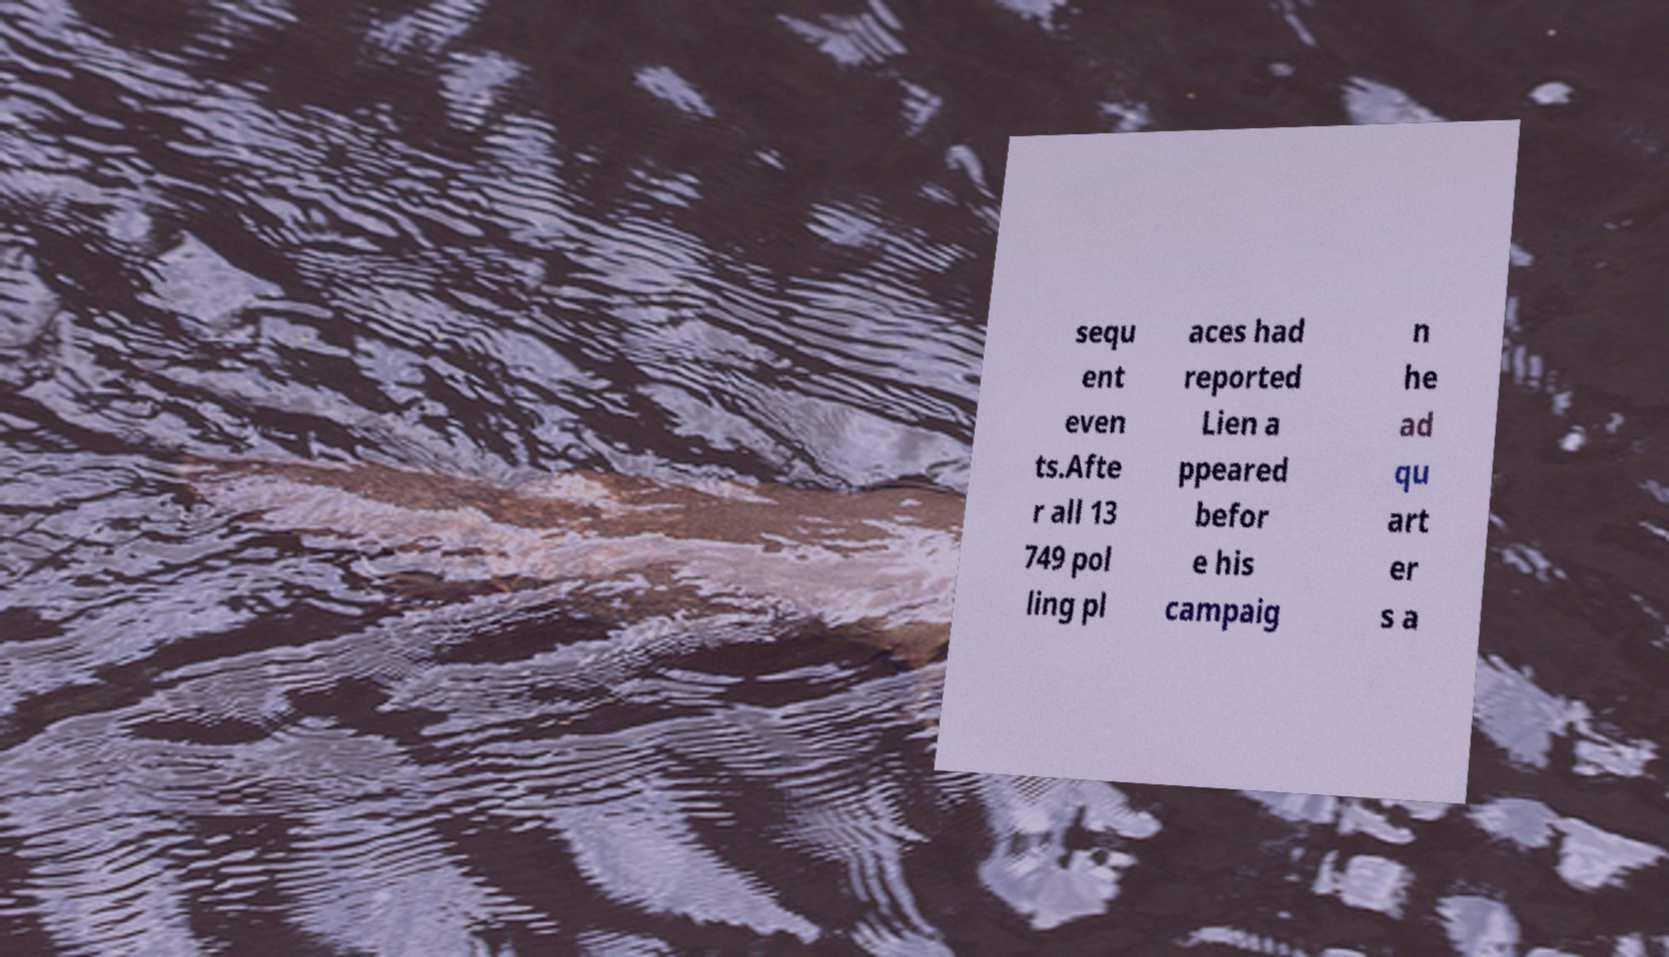Could you extract and type out the text from this image? sequ ent even ts.Afte r all 13 749 pol ling pl aces had reported Lien a ppeared befor e his campaig n he ad qu art er s a 